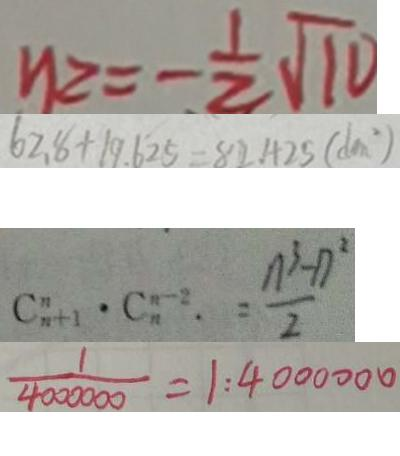<formula> <loc_0><loc_0><loc_500><loc_500>y 2 = - \frac { 1 } { 2 } \sqrt { 1 0 } 
 6 2 . 8 + 1 9 . 6 2 5 = 8 2 . 4 2 5 ( d m ^ { 2 } ) 
 C ^ { n } _ { n + 1 } \cdot C _ { n } ^ { n - 2 } . = \frac { n ^ { 3 } - n ^ { 3 } } { 2 } 
 \frac { 1 } { 4 0 0 0 0 0 } = 1 : 4 0 0 0 0 0 0</formula> 